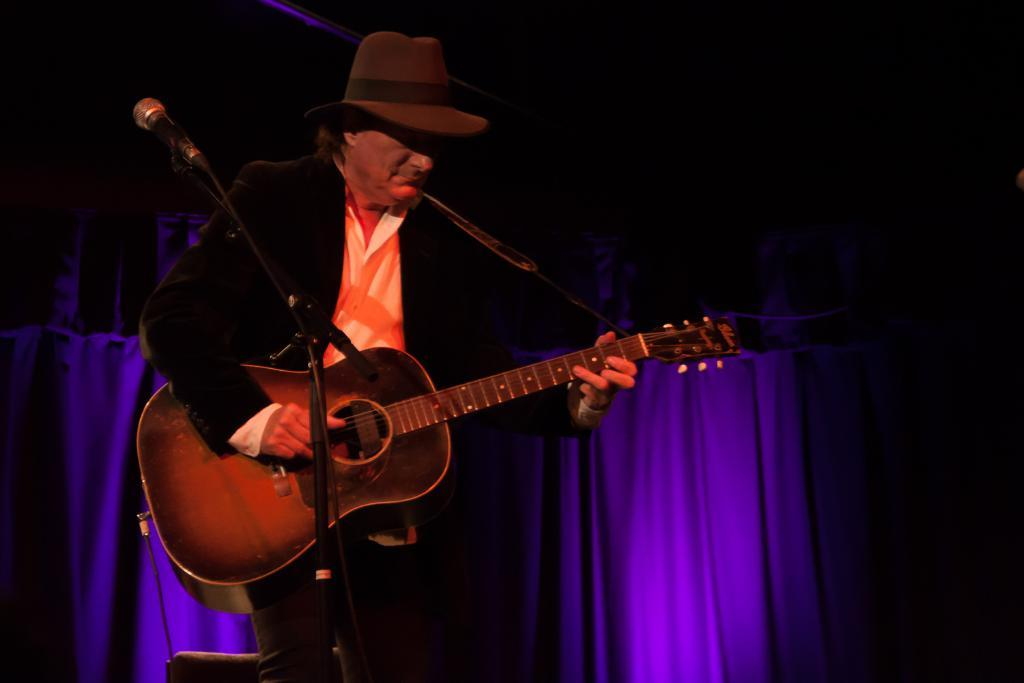What is the main subject of the image? There is a man in the image. What is the man doing in the image? The man is playing a guitar. What is the man wearing in the image? The man is wearing a suit. What object is in front of the man? There is a microphone in front of the man. How many fairies are dancing around the man's foot in the image? There are no fairies present in the image, and therefore no such activity can be observed. 